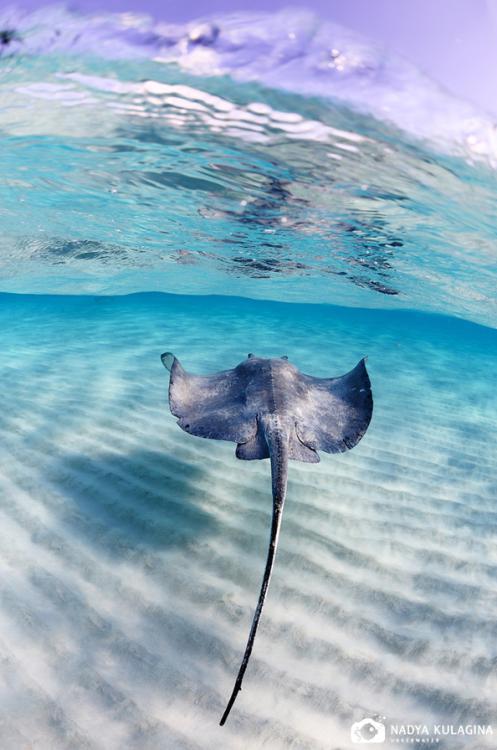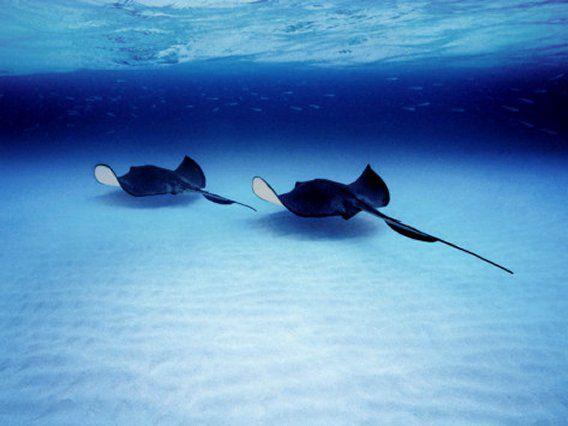The first image is the image on the left, the second image is the image on the right. Evaluate the accuracy of this statement regarding the images: "At least three sting rays are swimming in the water.". Is it true? Answer yes or no. Yes. The first image is the image on the left, the second image is the image on the right. Given the left and right images, does the statement "Each images shows just one stingray in the foreground." hold true? Answer yes or no. No. 